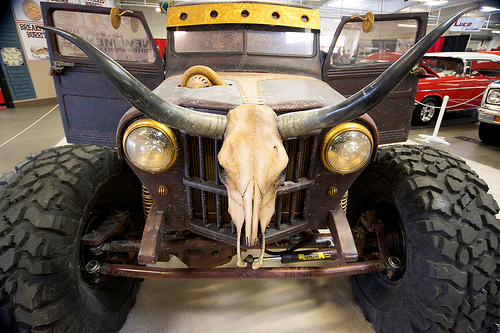<image>
Is there a skull on the car? Yes. Looking at the image, I can see the skull is positioned on top of the car, with the car providing support. 